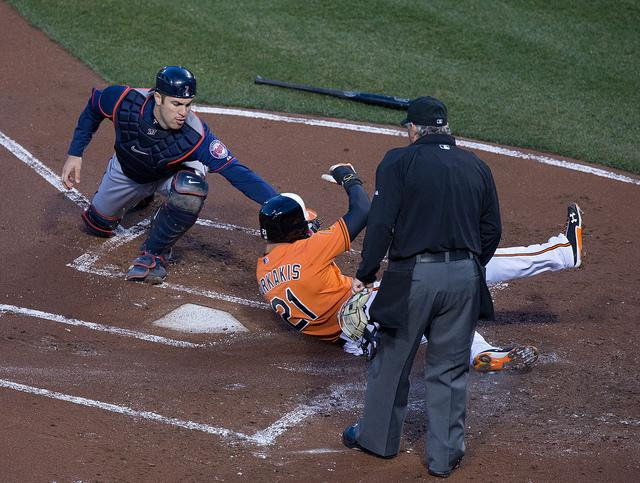What is the position of the man who is standing?

Choices:
A) umpire
B) pitcher
C) catcher
D) coach umpire 